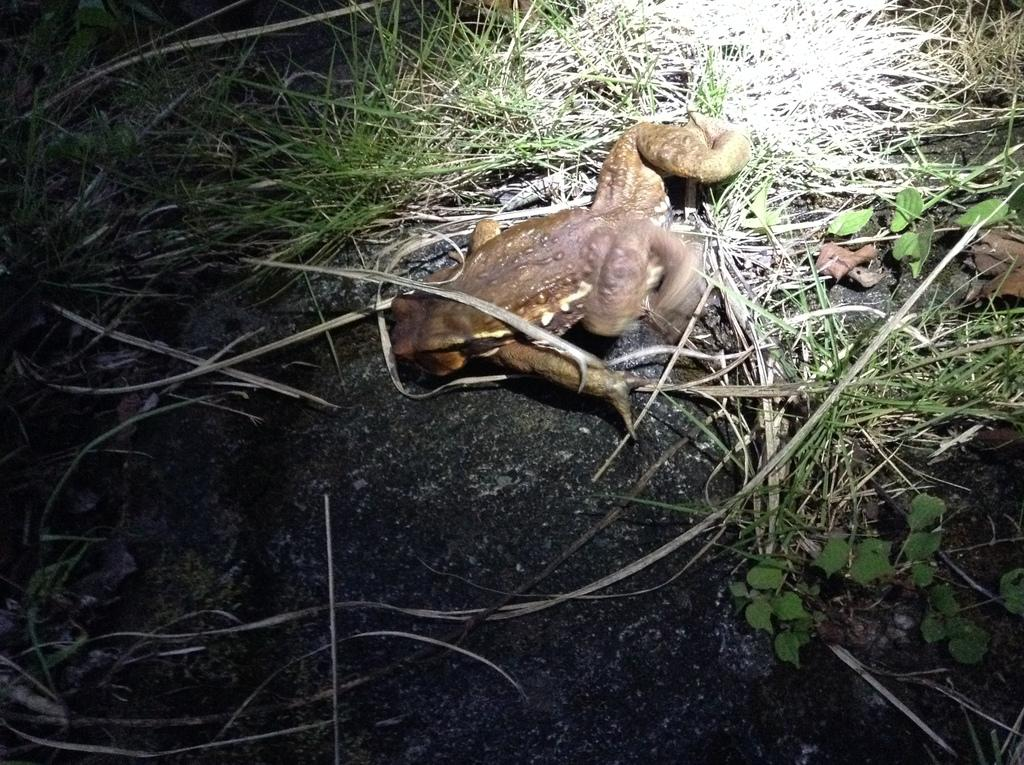What animal is the main subject of the picture? There is a frog in the picture. Where is the frog located in the image? The frog is on a rock. What type of vegetation can be seen in the background of the picture? There is grass in the background of the picture. How does the frog fold its arms in the picture? Frogs do not have arms to fold; they have legs for hopping. 